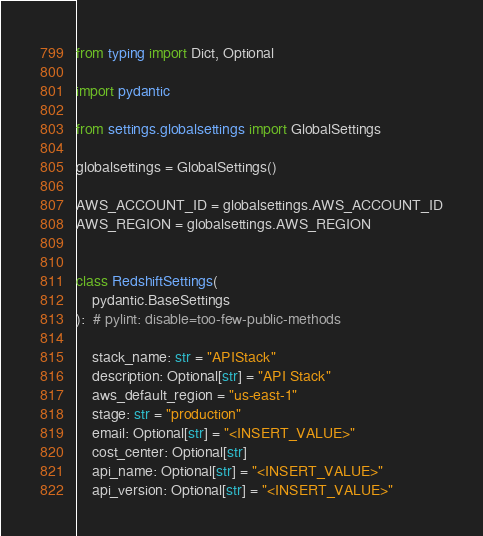<code> <loc_0><loc_0><loc_500><loc_500><_Python_>from typing import Dict, Optional

import pydantic

from settings.globalsettings import GlobalSettings

globalsettings = GlobalSettings()

AWS_ACCOUNT_ID = globalsettings.AWS_ACCOUNT_ID
AWS_REGION = globalsettings.AWS_REGION


class RedshiftSettings(
    pydantic.BaseSettings
):  # pylint: disable=too-few-public-methods

    stack_name: str = "APIStack"
    description: Optional[str] = "API Stack"
    aws_default_region = "us-east-1"
    stage: str = "production"
    email: Optional[str] = "<INSERT_VALUE>"
    cost_center: Optional[str]
    api_name: Optional[str] = "<INSERT_VALUE>"
    api_version: Optional[str] = "<INSERT_VALUE>"
</code> 